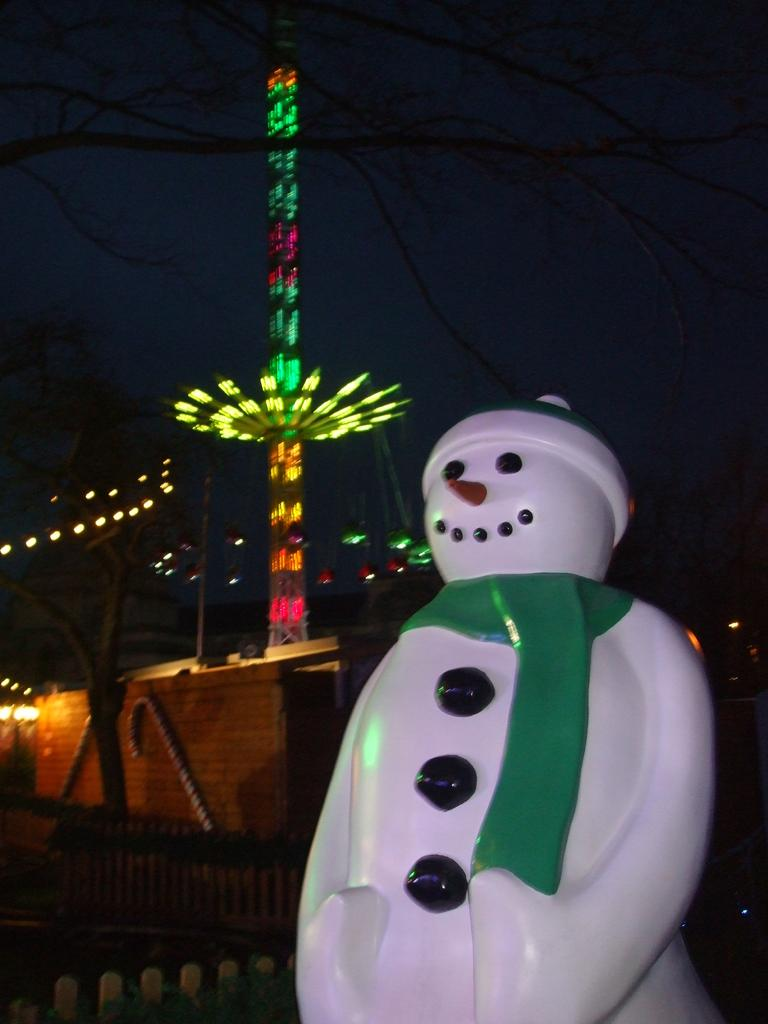What color is the doll on the right side of the image? The doll is in white color on the right side of the image. What object is located in the middle of the image? There is a circular wheel with lights in the middle of the image. What can be seen at the top of the image? The sky is visible at the top of the image. How many cats are visible in the image? There are no cats present in the image. What type of test is being conducted in the image? There is no test being conducted in the image; it features a doll and a circular wheel with lights. 